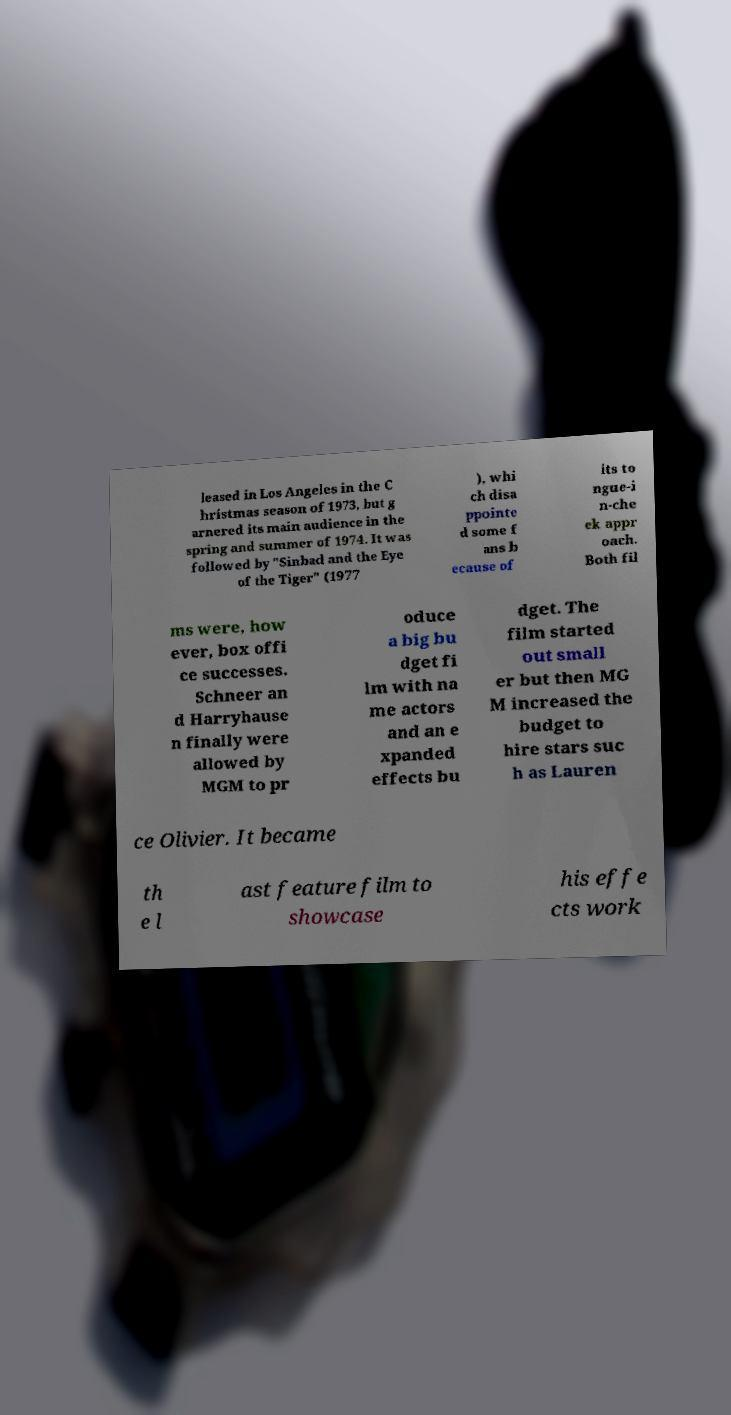What messages or text are displayed in this image? I need them in a readable, typed format. leased in Los Angeles in the C hristmas season of 1973, but g arnered its main audience in the spring and summer of 1974. It was followed by "Sinbad and the Eye of the Tiger" (1977 ), whi ch disa ppointe d some f ans b ecause of its to ngue-i n-che ek appr oach. Both fil ms were, how ever, box offi ce successes. Schneer an d Harryhause n finally were allowed by MGM to pr oduce a big bu dget fi lm with na me actors and an e xpanded effects bu dget. The film started out small er but then MG M increased the budget to hire stars suc h as Lauren ce Olivier. It became th e l ast feature film to showcase his effe cts work 